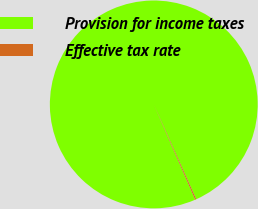Convert chart. <chart><loc_0><loc_0><loc_500><loc_500><pie_chart><fcel>Provision for income taxes<fcel>Effective tax rate<nl><fcel>99.82%<fcel>0.18%<nl></chart> 